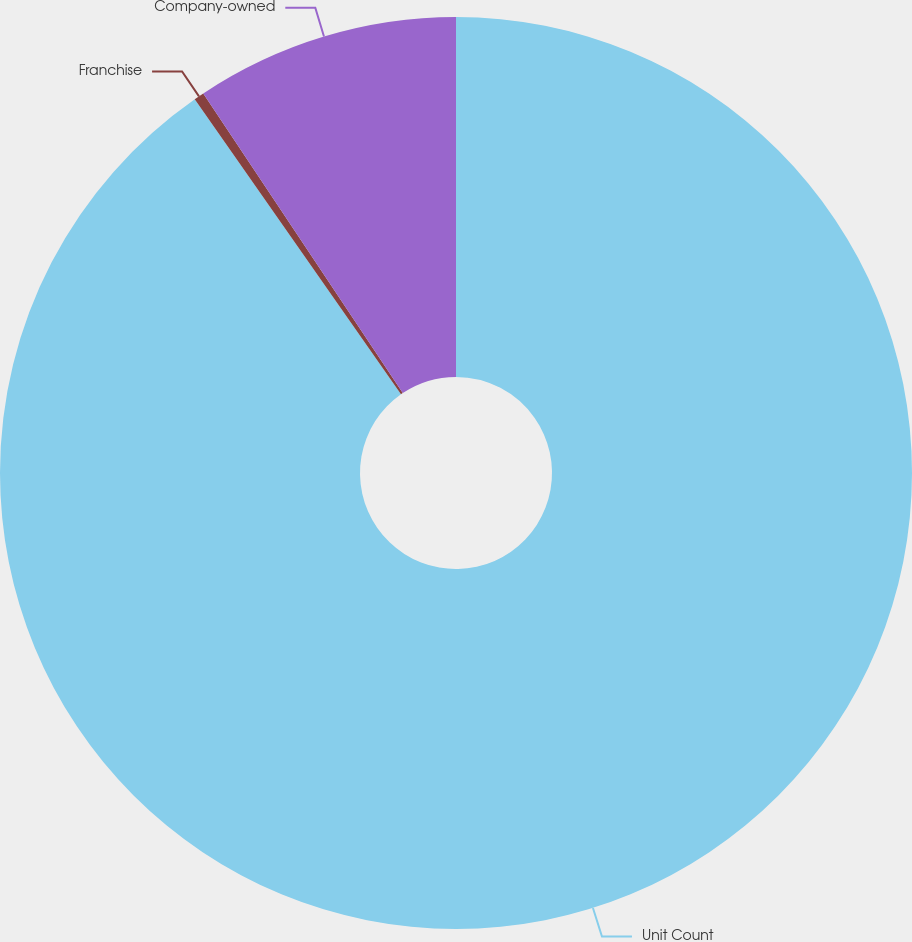<chart> <loc_0><loc_0><loc_500><loc_500><pie_chart><fcel>Unit Count<fcel>Franchise<fcel>Company-owned<nl><fcel>90.29%<fcel>0.36%<fcel>9.35%<nl></chart> 